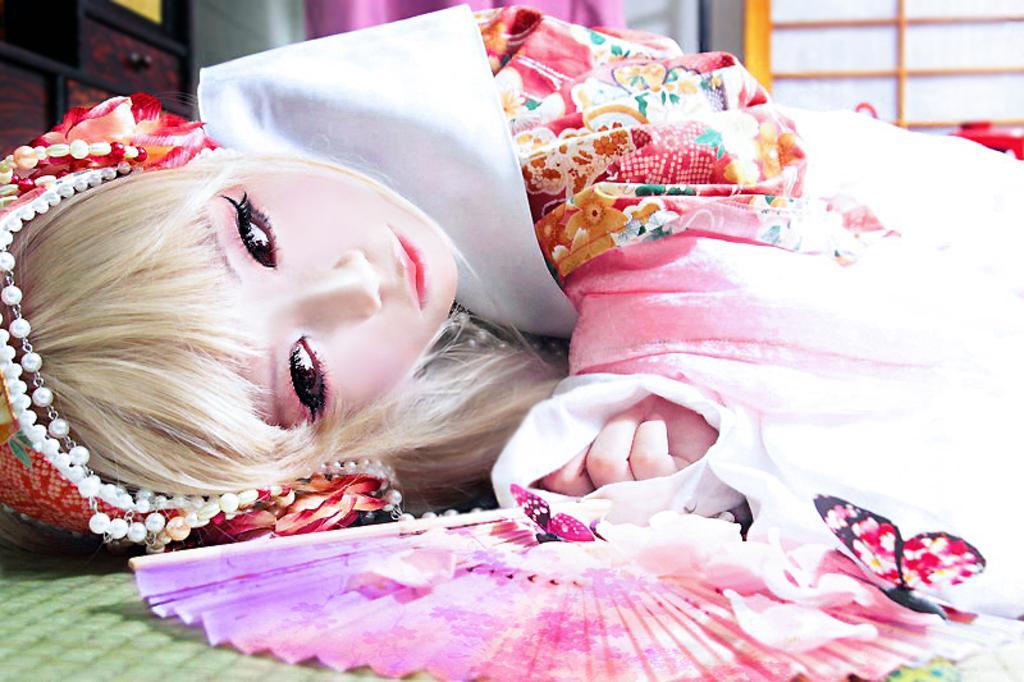Please provide a concise description of this image. In this picture we can see a woman in the fancy dress is laying on the path and behind the person there are drawers and other things. 